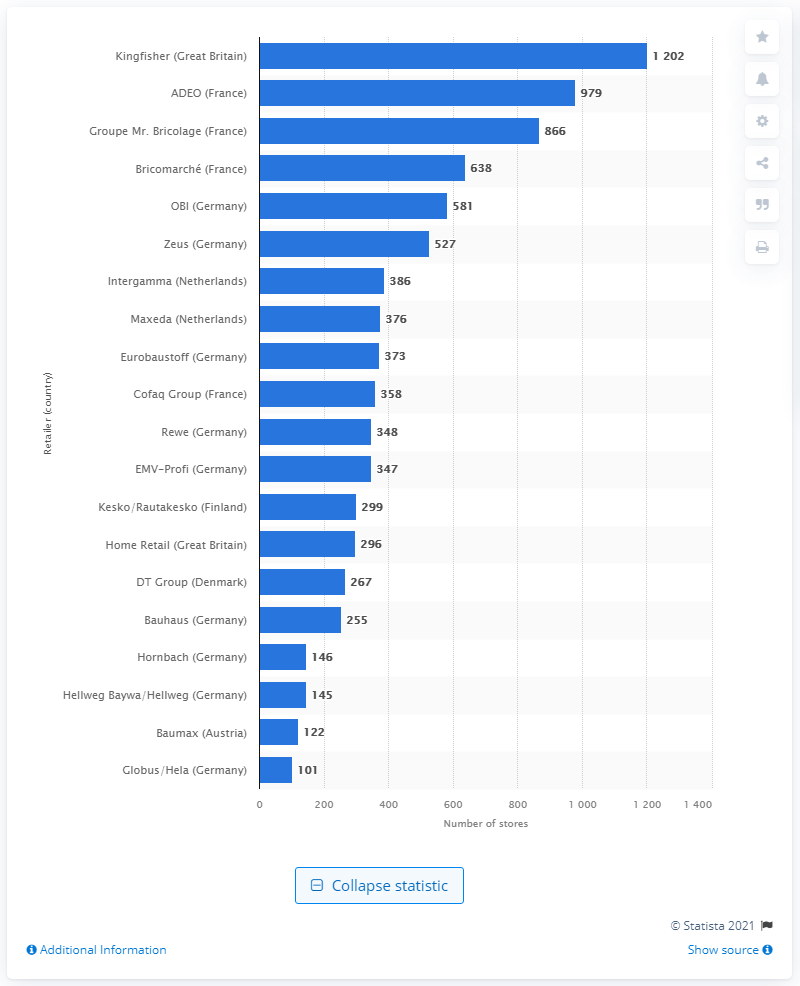Can you tell me which company had the second highest number of stores in 2014 according to this chart? Certainly, based on the chart, ADEO from France held the second-highest number of stores in 2014, with a total of 979 locations, showcasing its strong market presence in the home improvement sector. 